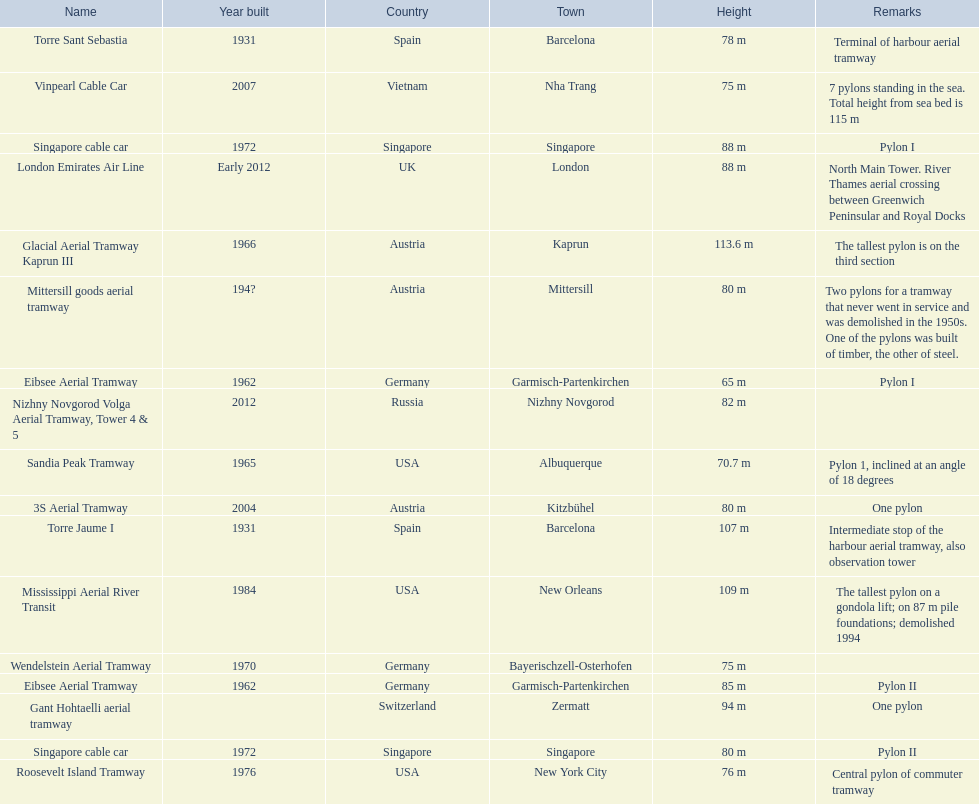What is the total number of pylons listed? 17. 